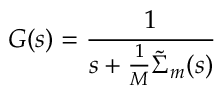Convert formula to latex. <formula><loc_0><loc_0><loc_500><loc_500>G ( s ) = \frac { 1 } { s + \frac { 1 } { M } \tilde { \Sigma } _ { m } ( s ) }</formula> 